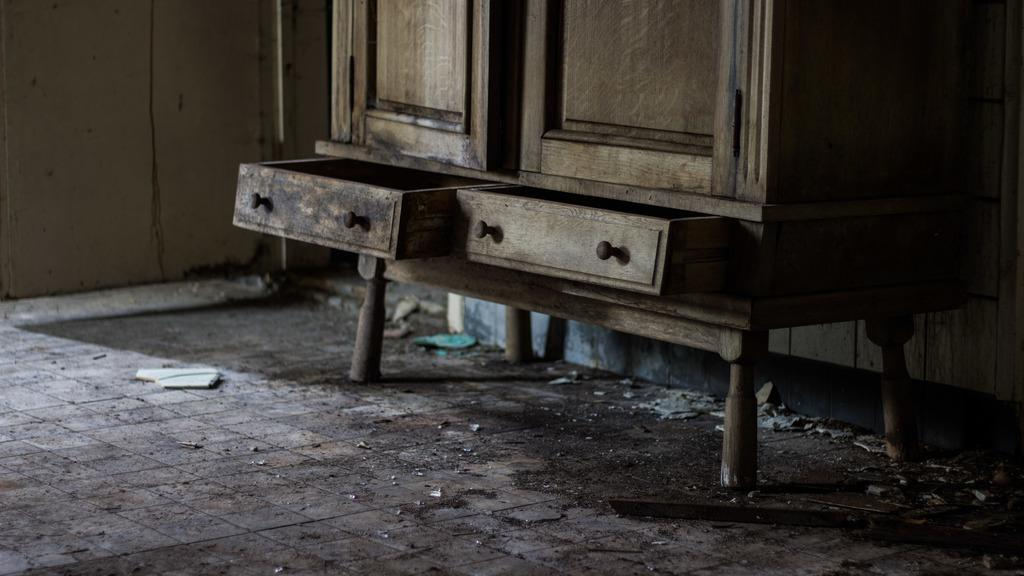What type of furniture is present in the image? There is a cupboard in the image. What color is the wall next to the cupboard? The wall beside the cupboard is white. What color dominates the right side of the image? The right side of the image is black in color. Can you describe the lighting conditions in the image? The image was taken in a dark environment. What is the plot of the story unfolding in the image? There is no story or plot present in the image; it is a static scene featuring a cupboard and a wall. 